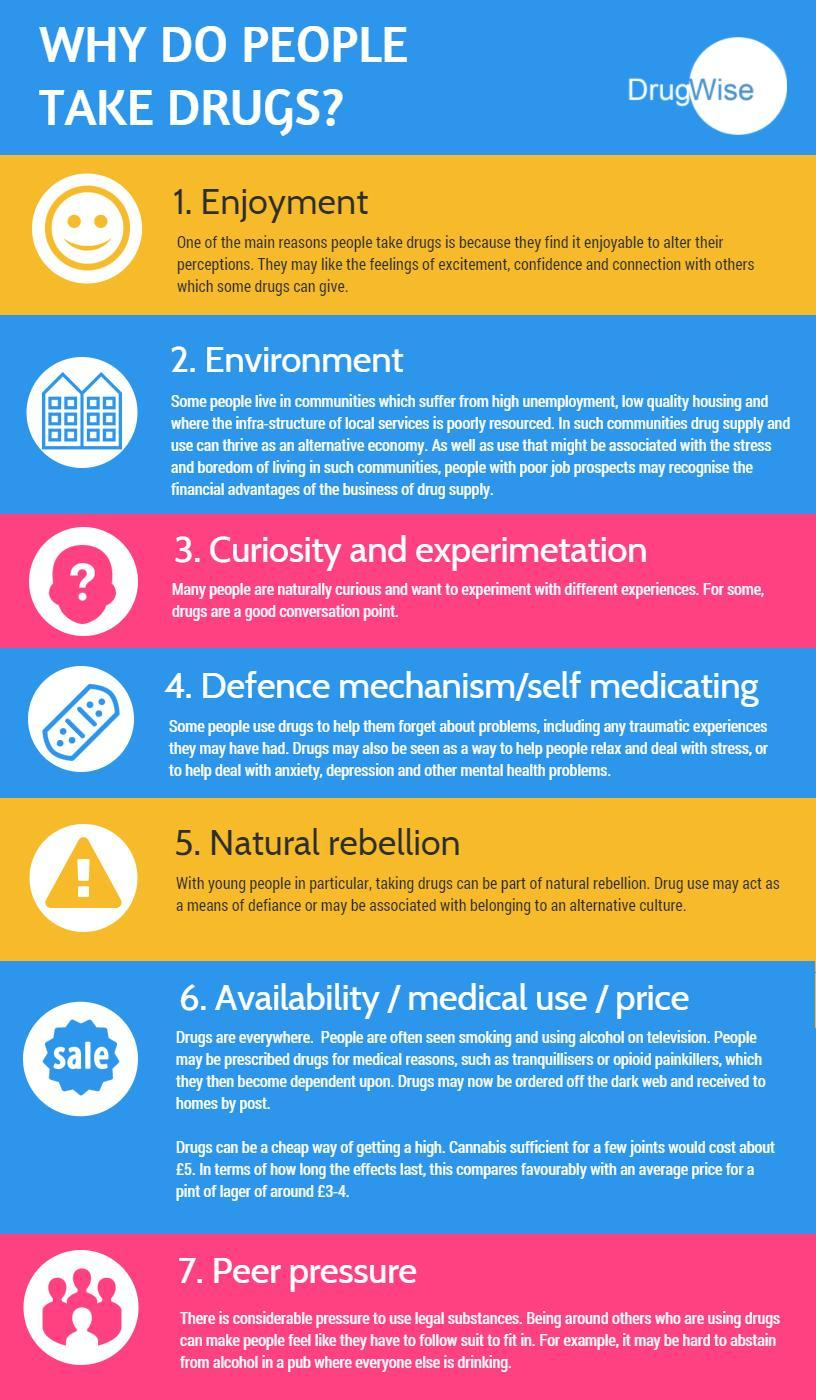What is the seventh reason for people to take drugs as listed in the infographic?
Answer the question with a short phrase. peer pressure What is the fifth reason for people to take drugs as listed in the infographic? natural rebellion 